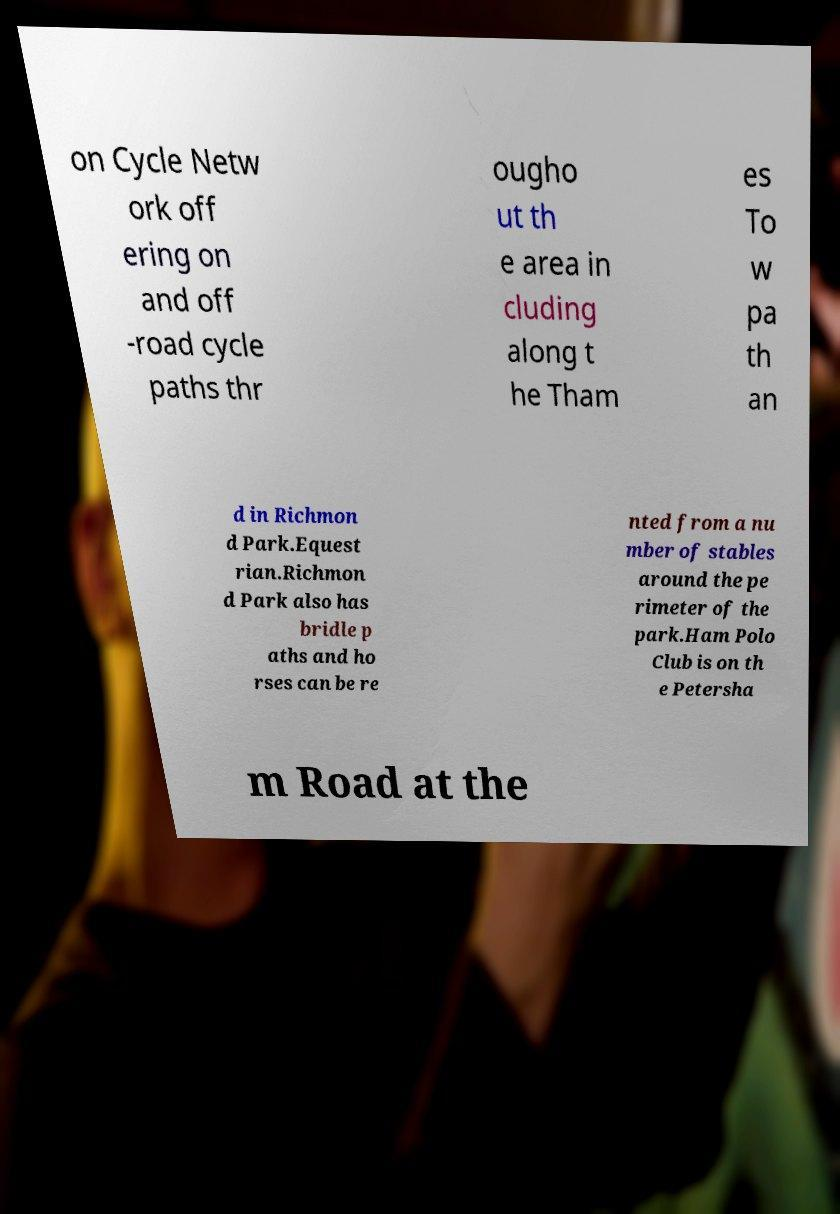I need the written content from this picture converted into text. Can you do that? on Cycle Netw ork off ering on and off -road cycle paths thr ougho ut th e area in cluding along t he Tham es To w pa th an d in Richmon d Park.Equest rian.Richmon d Park also has bridle p aths and ho rses can be re nted from a nu mber of stables around the pe rimeter of the park.Ham Polo Club is on th e Petersha m Road at the 